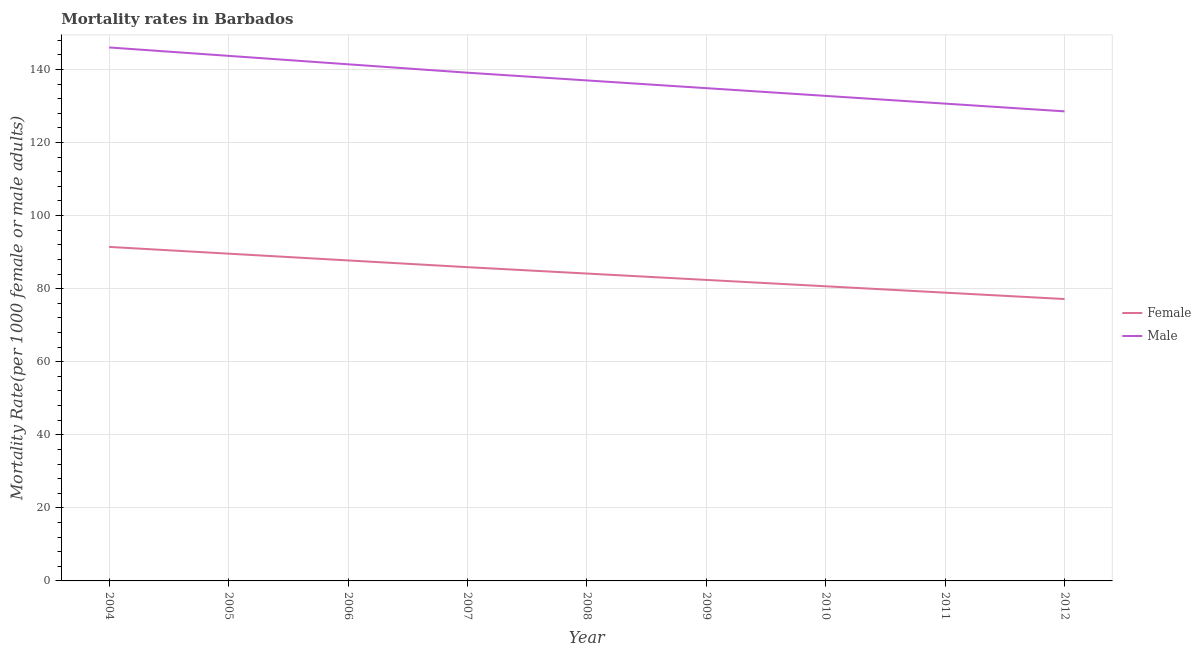Is the number of lines equal to the number of legend labels?
Offer a very short reply. Yes. What is the male mortality rate in 2011?
Your answer should be compact. 130.63. Across all years, what is the maximum female mortality rate?
Provide a short and direct response. 91.42. Across all years, what is the minimum female mortality rate?
Offer a very short reply. 77.15. In which year was the male mortality rate minimum?
Keep it short and to the point. 2012. What is the total female mortality rate in the graph?
Your response must be concise. 757.78. What is the difference between the female mortality rate in 2009 and that in 2011?
Your answer should be very brief. 3.49. What is the difference between the male mortality rate in 2010 and the female mortality rate in 2009?
Make the answer very short. 50.37. What is the average female mortality rate per year?
Keep it short and to the point. 84.2. In the year 2010, what is the difference between the female mortality rate and male mortality rate?
Offer a very short reply. -52.11. What is the ratio of the male mortality rate in 2006 to that in 2007?
Give a very brief answer. 1.02. Is the female mortality rate in 2008 less than that in 2009?
Your answer should be compact. No. What is the difference between the highest and the second highest male mortality rate?
Make the answer very short. 2.3. What is the difference between the highest and the lowest female mortality rate?
Make the answer very short. 14.26. In how many years, is the female mortality rate greater than the average female mortality rate taken over all years?
Give a very brief answer. 4. Does the female mortality rate monotonically increase over the years?
Provide a short and direct response. No. Is the male mortality rate strictly less than the female mortality rate over the years?
Provide a short and direct response. No. How many lines are there?
Ensure brevity in your answer.  2. Are the values on the major ticks of Y-axis written in scientific E-notation?
Give a very brief answer. No. Where does the legend appear in the graph?
Ensure brevity in your answer.  Center right. How many legend labels are there?
Offer a very short reply. 2. What is the title of the graph?
Keep it short and to the point. Mortality rates in Barbados. What is the label or title of the Y-axis?
Make the answer very short. Mortality Rate(per 1000 female or male adults). What is the Mortality Rate(per 1000 female or male adults) of Female in 2004?
Make the answer very short. 91.42. What is the Mortality Rate(per 1000 female or male adults) in Male in 2004?
Offer a very short reply. 146.01. What is the Mortality Rate(per 1000 female or male adults) of Female in 2005?
Offer a terse response. 89.57. What is the Mortality Rate(per 1000 female or male adults) of Male in 2005?
Give a very brief answer. 143.71. What is the Mortality Rate(per 1000 female or male adults) of Female in 2006?
Offer a terse response. 87.72. What is the Mortality Rate(per 1000 female or male adults) in Male in 2006?
Offer a terse response. 141.4. What is the Mortality Rate(per 1000 female or male adults) of Female in 2007?
Keep it short and to the point. 85.87. What is the Mortality Rate(per 1000 female or male adults) of Male in 2007?
Your answer should be compact. 139.1. What is the Mortality Rate(per 1000 female or male adults) of Female in 2008?
Your answer should be compact. 84.13. What is the Mortality Rate(per 1000 female or male adults) of Male in 2008?
Provide a short and direct response. 136.98. What is the Mortality Rate(per 1000 female or male adults) in Female in 2009?
Keep it short and to the point. 82.38. What is the Mortality Rate(per 1000 female or male adults) of Male in 2009?
Offer a very short reply. 134.87. What is the Mortality Rate(per 1000 female or male adults) in Female in 2010?
Your answer should be compact. 80.64. What is the Mortality Rate(per 1000 female or male adults) of Male in 2010?
Your answer should be very brief. 132.75. What is the Mortality Rate(per 1000 female or male adults) of Female in 2011?
Offer a very short reply. 78.9. What is the Mortality Rate(per 1000 female or male adults) in Male in 2011?
Your response must be concise. 130.63. What is the Mortality Rate(per 1000 female or male adults) in Female in 2012?
Your answer should be very brief. 77.15. What is the Mortality Rate(per 1000 female or male adults) in Male in 2012?
Your answer should be very brief. 128.52. Across all years, what is the maximum Mortality Rate(per 1000 female or male adults) of Female?
Provide a succinct answer. 91.42. Across all years, what is the maximum Mortality Rate(per 1000 female or male adults) in Male?
Your answer should be compact. 146.01. Across all years, what is the minimum Mortality Rate(per 1000 female or male adults) in Female?
Keep it short and to the point. 77.15. Across all years, what is the minimum Mortality Rate(per 1000 female or male adults) in Male?
Make the answer very short. 128.52. What is the total Mortality Rate(per 1000 female or male adults) in Female in the graph?
Your response must be concise. 757.78. What is the total Mortality Rate(per 1000 female or male adults) of Male in the graph?
Offer a very short reply. 1233.96. What is the difference between the Mortality Rate(per 1000 female or male adults) in Female in 2004 and that in 2005?
Your response must be concise. 1.85. What is the difference between the Mortality Rate(per 1000 female or male adults) of Male in 2004 and that in 2005?
Your answer should be very brief. 2.3. What is the difference between the Mortality Rate(per 1000 female or male adults) in Female in 2004 and that in 2006?
Keep it short and to the point. 3.7. What is the difference between the Mortality Rate(per 1000 female or male adults) of Male in 2004 and that in 2006?
Offer a very short reply. 4.61. What is the difference between the Mortality Rate(per 1000 female or male adults) of Female in 2004 and that in 2007?
Provide a succinct answer. 5.54. What is the difference between the Mortality Rate(per 1000 female or male adults) in Male in 2004 and that in 2007?
Provide a succinct answer. 6.91. What is the difference between the Mortality Rate(per 1000 female or male adults) of Female in 2004 and that in 2008?
Give a very brief answer. 7.29. What is the difference between the Mortality Rate(per 1000 female or male adults) in Male in 2004 and that in 2008?
Your response must be concise. 9.02. What is the difference between the Mortality Rate(per 1000 female or male adults) of Female in 2004 and that in 2009?
Offer a terse response. 9.03. What is the difference between the Mortality Rate(per 1000 female or male adults) of Male in 2004 and that in 2009?
Your response must be concise. 11.14. What is the difference between the Mortality Rate(per 1000 female or male adults) in Female in 2004 and that in 2010?
Provide a succinct answer. 10.78. What is the difference between the Mortality Rate(per 1000 female or male adults) in Male in 2004 and that in 2010?
Offer a very short reply. 13.26. What is the difference between the Mortality Rate(per 1000 female or male adults) in Female in 2004 and that in 2011?
Provide a short and direct response. 12.52. What is the difference between the Mortality Rate(per 1000 female or male adults) in Male in 2004 and that in 2011?
Your answer should be very brief. 15.37. What is the difference between the Mortality Rate(per 1000 female or male adults) of Female in 2004 and that in 2012?
Make the answer very short. 14.26. What is the difference between the Mortality Rate(per 1000 female or male adults) of Male in 2004 and that in 2012?
Your response must be concise. 17.49. What is the difference between the Mortality Rate(per 1000 female or male adults) in Female in 2005 and that in 2006?
Give a very brief answer. 1.85. What is the difference between the Mortality Rate(per 1000 female or male adults) in Male in 2005 and that in 2006?
Your answer should be compact. 2.3. What is the difference between the Mortality Rate(per 1000 female or male adults) of Female in 2005 and that in 2007?
Keep it short and to the point. 3.7. What is the difference between the Mortality Rate(per 1000 female or male adults) of Male in 2005 and that in 2007?
Provide a succinct answer. 4.61. What is the difference between the Mortality Rate(per 1000 female or male adults) in Female in 2005 and that in 2008?
Give a very brief answer. 5.44. What is the difference between the Mortality Rate(per 1000 female or male adults) in Male in 2005 and that in 2008?
Give a very brief answer. 6.72. What is the difference between the Mortality Rate(per 1000 female or male adults) of Female in 2005 and that in 2009?
Provide a succinct answer. 7.18. What is the difference between the Mortality Rate(per 1000 female or male adults) in Male in 2005 and that in 2009?
Your answer should be compact. 8.84. What is the difference between the Mortality Rate(per 1000 female or male adults) of Female in 2005 and that in 2010?
Your answer should be compact. 8.93. What is the difference between the Mortality Rate(per 1000 female or male adults) of Male in 2005 and that in 2010?
Provide a succinct answer. 10.96. What is the difference between the Mortality Rate(per 1000 female or male adults) in Female in 2005 and that in 2011?
Your answer should be compact. 10.67. What is the difference between the Mortality Rate(per 1000 female or male adults) in Male in 2005 and that in 2011?
Offer a very short reply. 13.07. What is the difference between the Mortality Rate(per 1000 female or male adults) in Female in 2005 and that in 2012?
Offer a terse response. 12.41. What is the difference between the Mortality Rate(per 1000 female or male adults) in Male in 2005 and that in 2012?
Your response must be concise. 15.19. What is the difference between the Mortality Rate(per 1000 female or male adults) in Female in 2006 and that in 2007?
Make the answer very short. 1.85. What is the difference between the Mortality Rate(per 1000 female or male adults) in Male in 2006 and that in 2007?
Offer a very short reply. 2.3. What is the difference between the Mortality Rate(per 1000 female or male adults) in Female in 2006 and that in 2008?
Ensure brevity in your answer.  3.59. What is the difference between the Mortality Rate(per 1000 female or male adults) in Male in 2006 and that in 2008?
Your response must be concise. 4.42. What is the difference between the Mortality Rate(per 1000 female or male adults) in Female in 2006 and that in 2009?
Give a very brief answer. 5.34. What is the difference between the Mortality Rate(per 1000 female or male adults) of Male in 2006 and that in 2009?
Provide a succinct answer. 6.54. What is the difference between the Mortality Rate(per 1000 female or male adults) of Female in 2006 and that in 2010?
Give a very brief answer. 7.08. What is the difference between the Mortality Rate(per 1000 female or male adults) of Male in 2006 and that in 2010?
Make the answer very short. 8.65. What is the difference between the Mortality Rate(per 1000 female or male adults) in Female in 2006 and that in 2011?
Give a very brief answer. 8.82. What is the difference between the Mortality Rate(per 1000 female or male adults) of Male in 2006 and that in 2011?
Make the answer very short. 10.77. What is the difference between the Mortality Rate(per 1000 female or male adults) in Female in 2006 and that in 2012?
Your response must be concise. 10.57. What is the difference between the Mortality Rate(per 1000 female or male adults) of Male in 2006 and that in 2012?
Ensure brevity in your answer.  12.89. What is the difference between the Mortality Rate(per 1000 female or male adults) in Female in 2007 and that in 2008?
Keep it short and to the point. 1.74. What is the difference between the Mortality Rate(per 1000 female or male adults) in Male in 2007 and that in 2008?
Your response must be concise. 2.12. What is the difference between the Mortality Rate(per 1000 female or male adults) of Female in 2007 and that in 2009?
Keep it short and to the point. 3.49. What is the difference between the Mortality Rate(per 1000 female or male adults) of Male in 2007 and that in 2009?
Your answer should be very brief. 4.23. What is the difference between the Mortality Rate(per 1000 female or male adults) in Female in 2007 and that in 2010?
Your answer should be very brief. 5.23. What is the difference between the Mortality Rate(per 1000 female or male adults) of Male in 2007 and that in 2010?
Offer a terse response. 6.35. What is the difference between the Mortality Rate(per 1000 female or male adults) in Female in 2007 and that in 2011?
Offer a terse response. 6.97. What is the difference between the Mortality Rate(per 1000 female or male adults) in Male in 2007 and that in 2011?
Provide a short and direct response. 8.47. What is the difference between the Mortality Rate(per 1000 female or male adults) in Female in 2007 and that in 2012?
Offer a terse response. 8.72. What is the difference between the Mortality Rate(per 1000 female or male adults) of Male in 2007 and that in 2012?
Your answer should be very brief. 10.58. What is the difference between the Mortality Rate(per 1000 female or male adults) in Female in 2008 and that in 2009?
Keep it short and to the point. 1.74. What is the difference between the Mortality Rate(per 1000 female or male adults) in Male in 2008 and that in 2009?
Give a very brief answer. 2.12. What is the difference between the Mortality Rate(per 1000 female or male adults) of Female in 2008 and that in 2010?
Offer a terse response. 3.49. What is the difference between the Mortality Rate(per 1000 female or male adults) in Male in 2008 and that in 2010?
Provide a succinct answer. 4.23. What is the difference between the Mortality Rate(per 1000 female or male adults) of Female in 2008 and that in 2011?
Your answer should be very brief. 5.23. What is the difference between the Mortality Rate(per 1000 female or male adults) of Male in 2008 and that in 2011?
Your response must be concise. 6.35. What is the difference between the Mortality Rate(per 1000 female or male adults) in Female in 2008 and that in 2012?
Ensure brevity in your answer.  6.97. What is the difference between the Mortality Rate(per 1000 female or male adults) in Male in 2008 and that in 2012?
Provide a short and direct response. 8.47. What is the difference between the Mortality Rate(per 1000 female or male adults) of Female in 2009 and that in 2010?
Keep it short and to the point. 1.74. What is the difference between the Mortality Rate(per 1000 female or male adults) in Male in 2009 and that in 2010?
Give a very brief answer. 2.12. What is the difference between the Mortality Rate(per 1000 female or male adults) of Female in 2009 and that in 2011?
Provide a short and direct response. 3.49. What is the difference between the Mortality Rate(per 1000 female or male adults) of Male in 2009 and that in 2011?
Your answer should be very brief. 4.23. What is the difference between the Mortality Rate(per 1000 female or male adults) of Female in 2009 and that in 2012?
Keep it short and to the point. 5.23. What is the difference between the Mortality Rate(per 1000 female or male adults) in Male in 2009 and that in 2012?
Ensure brevity in your answer.  6.35. What is the difference between the Mortality Rate(per 1000 female or male adults) in Female in 2010 and that in 2011?
Your answer should be compact. 1.74. What is the difference between the Mortality Rate(per 1000 female or male adults) in Male in 2010 and that in 2011?
Ensure brevity in your answer.  2.12. What is the difference between the Mortality Rate(per 1000 female or male adults) in Female in 2010 and that in 2012?
Your answer should be very brief. 3.49. What is the difference between the Mortality Rate(per 1000 female or male adults) in Male in 2010 and that in 2012?
Provide a succinct answer. 4.23. What is the difference between the Mortality Rate(per 1000 female or male adults) in Female in 2011 and that in 2012?
Make the answer very short. 1.74. What is the difference between the Mortality Rate(per 1000 female or male adults) of Male in 2011 and that in 2012?
Make the answer very short. 2.12. What is the difference between the Mortality Rate(per 1000 female or male adults) in Female in 2004 and the Mortality Rate(per 1000 female or male adults) in Male in 2005?
Make the answer very short. -52.29. What is the difference between the Mortality Rate(per 1000 female or male adults) in Female in 2004 and the Mortality Rate(per 1000 female or male adults) in Male in 2006?
Provide a succinct answer. -49.99. What is the difference between the Mortality Rate(per 1000 female or male adults) in Female in 2004 and the Mortality Rate(per 1000 female or male adults) in Male in 2007?
Ensure brevity in your answer.  -47.68. What is the difference between the Mortality Rate(per 1000 female or male adults) of Female in 2004 and the Mortality Rate(per 1000 female or male adults) of Male in 2008?
Your answer should be compact. -45.57. What is the difference between the Mortality Rate(per 1000 female or male adults) of Female in 2004 and the Mortality Rate(per 1000 female or male adults) of Male in 2009?
Provide a succinct answer. -43.45. What is the difference between the Mortality Rate(per 1000 female or male adults) in Female in 2004 and the Mortality Rate(per 1000 female or male adults) in Male in 2010?
Ensure brevity in your answer.  -41.33. What is the difference between the Mortality Rate(per 1000 female or male adults) in Female in 2004 and the Mortality Rate(per 1000 female or male adults) in Male in 2011?
Your answer should be compact. -39.22. What is the difference between the Mortality Rate(per 1000 female or male adults) of Female in 2004 and the Mortality Rate(per 1000 female or male adults) of Male in 2012?
Provide a short and direct response. -37.1. What is the difference between the Mortality Rate(per 1000 female or male adults) in Female in 2005 and the Mortality Rate(per 1000 female or male adults) in Male in 2006?
Give a very brief answer. -51.83. What is the difference between the Mortality Rate(per 1000 female or male adults) in Female in 2005 and the Mortality Rate(per 1000 female or male adults) in Male in 2007?
Ensure brevity in your answer.  -49.53. What is the difference between the Mortality Rate(per 1000 female or male adults) of Female in 2005 and the Mortality Rate(per 1000 female or male adults) of Male in 2008?
Make the answer very short. -47.41. What is the difference between the Mortality Rate(per 1000 female or male adults) of Female in 2005 and the Mortality Rate(per 1000 female or male adults) of Male in 2009?
Make the answer very short. -45.3. What is the difference between the Mortality Rate(per 1000 female or male adults) of Female in 2005 and the Mortality Rate(per 1000 female or male adults) of Male in 2010?
Make the answer very short. -43.18. What is the difference between the Mortality Rate(per 1000 female or male adults) of Female in 2005 and the Mortality Rate(per 1000 female or male adults) of Male in 2011?
Offer a terse response. -41.06. What is the difference between the Mortality Rate(per 1000 female or male adults) of Female in 2005 and the Mortality Rate(per 1000 female or male adults) of Male in 2012?
Offer a very short reply. -38.95. What is the difference between the Mortality Rate(per 1000 female or male adults) in Female in 2006 and the Mortality Rate(per 1000 female or male adults) in Male in 2007?
Make the answer very short. -51.38. What is the difference between the Mortality Rate(per 1000 female or male adults) of Female in 2006 and the Mortality Rate(per 1000 female or male adults) of Male in 2008?
Give a very brief answer. -49.26. What is the difference between the Mortality Rate(per 1000 female or male adults) of Female in 2006 and the Mortality Rate(per 1000 female or male adults) of Male in 2009?
Ensure brevity in your answer.  -47.15. What is the difference between the Mortality Rate(per 1000 female or male adults) in Female in 2006 and the Mortality Rate(per 1000 female or male adults) in Male in 2010?
Your answer should be very brief. -45.03. What is the difference between the Mortality Rate(per 1000 female or male adults) of Female in 2006 and the Mortality Rate(per 1000 female or male adults) of Male in 2011?
Give a very brief answer. -42.91. What is the difference between the Mortality Rate(per 1000 female or male adults) of Female in 2006 and the Mortality Rate(per 1000 female or male adults) of Male in 2012?
Keep it short and to the point. -40.8. What is the difference between the Mortality Rate(per 1000 female or male adults) of Female in 2007 and the Mortality Rate(per 1000 female or male adults) of Male in 2008?
Your response must be concise. -51.11. What is the difference between the Mortality Rate(per 1000 female or male adults) in Female in 2007 and the Mortality Rate(per 1000 female or male adults) in Male in 2009?
Provide a short and direct response. -48.99. What is the difference between the Mortality Rate(per 1000 female or male adults) in Female in 2007 and the Mortality Rate(per 1000 female or male adults) in Male in 2010?
Your response must be concise. -46.88. What is the difference between the Mortality Rate(per 1000 female or male adults) of Female in 2007 and the Mortality Rate(per 1000 female or male adults) of Male in 2011?
Provide a succinct answer. -44.76. What is the difference between the Mortality Rate(per 1000 female or male adults) of Female in 2007 and the Mortality Rate(per 1000 female or male adults) of Male in 2012?
Offer a very short reply. -42.64. What is the difference between the Mortality Rate(per 1000 female or male adults) of Female in 2008 and the Mortality Rate(per 1000 female or male adults) of Male in 2009?
Provide a short and direct response. -50.74. What is the difference between the Mortality Rate(per 1000 female or male adults) in Female in 2008 and the Mortality Rate(per 1000 female or male adults) in Male in 2010?
Your answer should be very brief. -48.62. What is the difference between the Mortality Rate(per 1000 female or male adults) in Female in 2008 and the Mortality Rate(per 1000 female or male adults) in Male in 2011?
Provide a succinct answer. -46.51. What is the difference between the Mortality Rate(per 1000 female or male adults) in Female in 2008 and the Mortality Rate(per 1000 female or male adults) in Male in 2012?
Your answer should be compact. -44.39. What is the difference between the Mortality Rate(per 1000 female or male adults) of Female in 2009 and the Mortality Rate(per 1000 female or male adults) of Male in 2010?
Your response must be concise. -50.37. What is the difference between the Mortality Rate(per 1000 female or male adults) of Female in 2009 and the Mortality Rate(per 1000 female or male adults) of Male in 2011?
Provide a succinct answer. -48.25. What is the difference between the Mortality Rate(per 1000 female or male adults) of Female in 2009 and the Mortality Rate(per 1000 female or male adults) of Male in 2012?
Your answer should be very brief. -46.13. What is the difference between the Mortality Rate(per 1000 female or male adults) in Female in 2010 and the Mortality Rate(per 1000 female or male adults) in Male in 2011?
Your response must be concise. -49.99. What is the difference between the Mortality Rate(per 1000 female or male adults) in Female in 2010 and the Mortality Rate(per 1000 female or male adults) in Male in 2012?
Your answer should be very brief. -47.88. What is the difference between the Mortality Rate(per 1000 female or male adults) of Female in 2011 and the Mortality Rate(per 1000 female or male adults) of Male in 2012?
Provide a short and direct response. -49.62. What is the average Mortality Rate(per 1000 female or male adults) of Female per year?
Your response must be concise. 84.2. What is the average Mortality Rate(per 1000 female or male adults) of Male per year?
Ensure brevity in your answer.  137.11. In the year 2004, what is the difference between the Mortality Rate(per 1000 female or male adults) of Female and Mortality Rate(per 1000 female or male adults) of Male?
Your answer should be compact. -54.59. In the year 2005, what is the difference between the Mortality Rate(per 1000 female or male adults) of Female and Mortality Rate(per 1000 female or male adults) of Male?
Your answer should be very brief. -54.14. In the year 2006, what is the difference between the Mortality Rate(per 1000 female or male adults) of Female and Mortality Rate(per 1000 female or male adults) of Male?
Keep it short and to the point. -53.68. In the year 2007, what is the difference between the Mortality Rate(per 1000 female or male adults) of Female and Mortality Rate(per 1000 female or male adults) of Male?
Your answer should be very brief. -53.23. In the year 2008, what is the difference between the Mortality Rate(per 1000 female or male adults) of Female and Mortality Rate(per 1000 female or male adults) of Male?
Your answer should be compact. -52.85. In the year 2009, what is the difference between the Mortality Rate(per 1000 female or male adults) in Female and Mortality Rate(per 1000 female or male adults) in Male?
Provide a short and direct response. -52.48. In the year 2010, what is the difference between the Mortality Rate(per 1000 female or male adults) of Female and Mortality Rate(per 1000 female or male adults) of Male?
Provide a short and direct response. -52.11. In the year 2011, what is the difference between the Mortality Rate(per 1000 female or male adults) of Female and Mortality Rate(per 1000 female or male adults) of Male?
Offer a terse response. -51.74. In the year 2012, what is the difference between the Mortality Rate(per 1000 female or male adults) in Female and Mortality Rate(per 1000 female or male adults) in Male?
Give a very brief answer. -51.36. What is the ratio of the Mortality Rate(per 1000 female or male adults) of Female in 2004 to that in 2005?
Your response must be concise. 1.02. What is the ratio of the Mortality Rate(per 1000 female or male adults) of Female in 2004 to that in 2006?
Provide a short and direct response. 1.04. What is the ratio of the Mortality Rate(per 1000 female or male adults) in Male in 2004 to that in 2006?
Give a very brief answer. 1.03. What is the ratio of the Mortality Rate(per 1000 female or male adults) of Female in 2004 to that in 2007?
Provide a short and direct response. 1.06. What is the ratio of the Mortality Rate(per 1000 female or male adults) of Male in 2004 to that in 2007?
Offer a terse response. 1.05. What is the ratio of the Mortality Rate(per 1000 female or male adults) of Female in 2004 to that in 2008?
Ensure brevity in your answer.  1.09. What is the ratio of the Mortality Rate(per 1000 female or male adults) in Male in 2004 to that in 2008?
Provide a succinct answer. 1.07. What is the ratio of the Mortality Rate(per 1000 female or male adults) of Female in 2004 to that in 2009?
Provide a short and direct response. 1.11. What is the ratio of the Mortality Rate(per 1000 female or male adults) of Male in 2004 to that in 2009?
Make the answer very short. 1.08. What is the ratio of the Mortality Rate(per 1000 female or male adults) in Female in 2004 to that in 2010?
Your answer should be compact. 1.13. What is the ratio of the Mortality Rate(per 1000 female or male adults) of Male in 2004 to that in 2010?
Your answer should be very brief. 1.1. What is the ratio of the Mortality Rate(per 1000 female or male adults) of Female in 2004 to that in 2011?
Offer a very short reply. 1.16. What is the ratio of the Mortality Rate(per 1000 female or male adults) of Male in 2004 to that in 2011?
Provide a succinct answer. 1.12. What is the ratio of the Mortality Rate(per 1000 female or male adults) of Female in 2004 to that in 2012?
Provide a short and direct response. 1.18. What is the ratio of the Mortality Rate(per 1000 female or male adults) in Male in 2004 to that in 2012?
Give a very brief answer. 1.14. What is the ratio of the Mortality Rate(per 1000 female or male adults) of Female in 2005 to that in 2006?
Give a very brief answer. 1.02. What is the ratio of the Mortality Rate(per 1000 female or male adults) in Male in 2005 to that in 2006?
Your answer should be compact. 1.02. What is the ratio of the Mortality Rate(per 1000 female or male adults) in Female in 2005 to that in 2007?
Your response must be concise. 1.04. What is the ratio of the Mortality Rate(per 1000 female or male adults) of Male in 2005 to that in 2007?
Your answer should be very brief. 1.03. What is the ratio of the Mortality Rate(per 1000 female or male adults) in Female in 2005 to that in 2008?
Make the answer very short. 1.06. What is the ratio of the Mortality Rate(per 1000 female or male adults) in Male in 2005 to that in 2008?
Your response must be concise. 1.05. What is the ratio of the Mortality Rate(per 1000 female or male adults) of Female in 2005 to that in 2009?
Your response must be concise. 1.09. What is the ratio of the Mortality Rate(per 1000 female or male adults) in Male in 2005 to that in 2009?
Provide a short and direct response. 1.07. What is the ratio of the Mortality Rate(per 1000 female or male adults) in Female in 2005 to that in 2010?
Ensure brevity in your answer.  1.11. What is the ratio of the Mortality Rate(per 1000 female or male adults) in Male in 2005 to that in 2010?
Provide a succinct answer. 1.08. What is the ratio of the Mortality Rate(per 1000 female or male adults) of Female in 2005 to that in 2011?
Provide a short and direct response. 1.14. What is the ratio of the Mortality Rate(per 1000 female or male adults) in Male in 2005 to that in 2011?
Ensure brevity in your answer.  1.1. What is the ratio of the Mortality Rate(per 1000 female or male adults) in Female in 2005 to that in 2012?
Provide a succinct answer. 1.16. What is the ratio of the Mortality Rate(per 1000 female or male adults) of Male in 2005 to that in 2012?
Ensure brevity in your answer.  1.12. What is the ratio of the Mortality Rate(per 1000 female or male adults) of Female in 2006 to that in 2007?
Ensure brevity in your answer.  1.02. What is the ratio of the Mortality Rate(per 1000 female or male adults) in Male in 2006 to that in 2007?
Give a very brief answer. 1.02. What is the ratio of the Mortality Rate(per 1000 female or male adults) of Female in 2006 to that in 2008?
Offer a very short reply. 1.04. What is the ratio of the Mortality Rate(per 1000 female or male adults) of Male in 2006 to that in 2008?
Offer a very short reply. 1.03. What is the ratio of the Mortality Rate(per 1000 female or male adults) of Female in 2006 to that in 2009?
Your answer should be compact. 1.06. What is the ratio of the Mortality Rate(per 1000 female or male adults) of Male in 2006 to that in 2009?
Make the answer very short. 1.05. What is the ratio of the Mortality Rate(per 1000 female or male adults) of Female in 2006 to that in 2010?
Keep it short and to the point. 1.09. What is the ratio of the Mortality Rate(per 1000 female or male adults) in Male in 2006 to that in 2010?
Make the answer very short. 1.07. What is the ratio of the Mortality Rate(per 1000 female or male adults) of Female in 2006 to that in 2011?
Offer a very short reply. 1.11. What is the ratio of the Mortality Rate(per 1000 female or male adults) in Male in 2006 to that in 2011?
Give a very brief answer. 1.08. What is the ratio of the Mortality Rate(per 1000 female or male adults) of Female in 2006 to that in 2012?
Your answer should be very brief. 1.14. What is the ratio of the Mortality Rate(per 1000 female or male adults) of Male in 2006 to that in 2012?
Your answer should be compact. 1.1. What is the ratio of the Mortality Rate(per 1000 female or male adults) in Female in 2007 to that in 2008?
Your response must be concise. 1.02. What is the ratio of the Mortality Rate(per 1000 female or male adults) of Male in 2007 to that in 2008?
Offer a very short reply. 1.02. What is the ratio of the Mortality Rate(per 1000 female or male adults) in Female in 2007 to that in 2009?
Give a very brief answer. 1.04. What is the ratio of the Mortality Rate(per 1000 female or male adults) of Male in 2007 to that in 2009?
Provide a short and direct response. 1.03. What is the ratio of the Mortality Rate(per 1000 female or male adults) of Female in 2007 to that in 2010?
Keep it short and to the point. 1.06. What is the ratio of the Mortality Rate(per 1000 female or male adults) in Male in 2007 to that in 2010?
Provide a short and direct response. 1.05. What is the ratio of the Mortality Rate(per 1000 female or male adults) in Female in 2007 to that in 2011?
Make the answer very short. 1.09. What is the ratio of the Mortality Rate(per 1000 female or male adults) in Male in 2007 to that in 2011?
Your response must be concise. 1.06. What is the ratio of the Mortality Rate(per 1000 female or male adults) of Female in 2007 to that in 2012?
Your response must be concise. 1.11. What is the ratio of the Mortality Rate(per 1000 female or male adults) in Male in 2007 to that in 2012?
Your answer should be very brief. 1.08. What is the ratio of the Mortality Rate(per 1000 female or male adults) of Female in 2008 to that in 2009?
Ensure brevity in your answer.  1.02. What is the ratio of the Mortality Rate(per 1000 female or male adults) of Male in 2008 to that in 2009?
Give a very brief answer. 1.02. What is the ratio of the Mortality Rate(per 1000 female or male adults) in Female in 2008 to that in 2010?
Your answer should be compact. 1.04. What is the ratio of the Mortality Rate(per 1000 female or male adults) of Male in 2008 to that in 2010?
Your answer should be compact. 1.03. What is the ratio of the Mortality Rate(per 1000 female or male adults) of Female in 2008 to that in 2011?
Make the answer very short. 1.07. What is the ratio of the Mortality Rate(per 1000 female or male adults) in Male in 2008 to that in 2011?
Provide a succinct answer. 1.05. What is the ratio of the Mortality Rate(per 1000 female or male adults) in Female in 2008 to that in 2012?
Your answer should be compact. 1.09. What is the ratio of the Mortality Rate(per 1000 female or male adults) in Male in 2008 to that in 2012?
Provide a short and direct response. 1.07. What is the ratio of the Mortality Rate(per 1000 female or male adults) of Female in 2009 to that in 2010?
Offer a terse response. 1.02. What is the ratio of the Mortality Rate(per 1000 female or male adults) in Male in 2009 to that in 2010?
Keep it short and to the point. 1.02. What is the ratio of the Mortality Rate(per 1000 female or male adults) of Female in 2009 to that in 2011?
Offer a very short reply. 1.04. What is the ratio of the Mortality Rate(per 1000 female or male adults) of Male in 2009 to that in 2011?
Provide a succinct answer. 1.03. What is the ratio of the Mortality Rate(per 1000 female or male adults) of Female in 2009 to that in 2012?
Offer a very short reply. 1.07. What is the ratio of the Mortality Rate(per 1000 female or male adults) in Male in 2009 to that in 2012?
Offer a terse response. 1.05. What is the ratio of the Mortality Rate(per 1000 female or male adults) of Female in 2010 to that in 2011?
Keep it short and to the point. 1.02. What is the ratio of the Mortality Rate(per 1000 female or male adults) in Male in 2010 to that in 2011?
Give a very brief answer. 1.02. What is the ratio of the Mortality Rate(per 1000 female or male adults) of Female in 2010 to that in 2012?
Ensure brevity in your answer.  1.05. What is the ratio of the Mortality Rate(per 1000 female or male adults) of Male in 2010 to that in 2012?
Offer a terse response. 1.03. What is the ratio of the Mortality Rate(per 1000 female or male adults) in Female in 2011 to that in 2012?
Offer a very short reply. 1.02. What is the ratio of the Mortality Rate(per 1000 female or male adults) of Male in 2011 to that in 2012?
Provide a short and direct response. 1.02. What is the difference between the highest and the second highest Mortality Rate(per 1000 female or male adults) in Female?
Offer a very short reply. 1.85. What is the difference between the highest and the second highest Mortality Rate(per 1000 female or male adults) in Male?
Ensure brevity in your answer.  2.3. What is the difference between the highest and the lowest Mortality Rate(per 1000 female or male adults) of Female?
Your answer should be very brief. 14.26. What is the difference between the highest and the lowest Mortality Rate(per 1000 female or male adults) in Male?
Offer a very short reply. 17.49. 